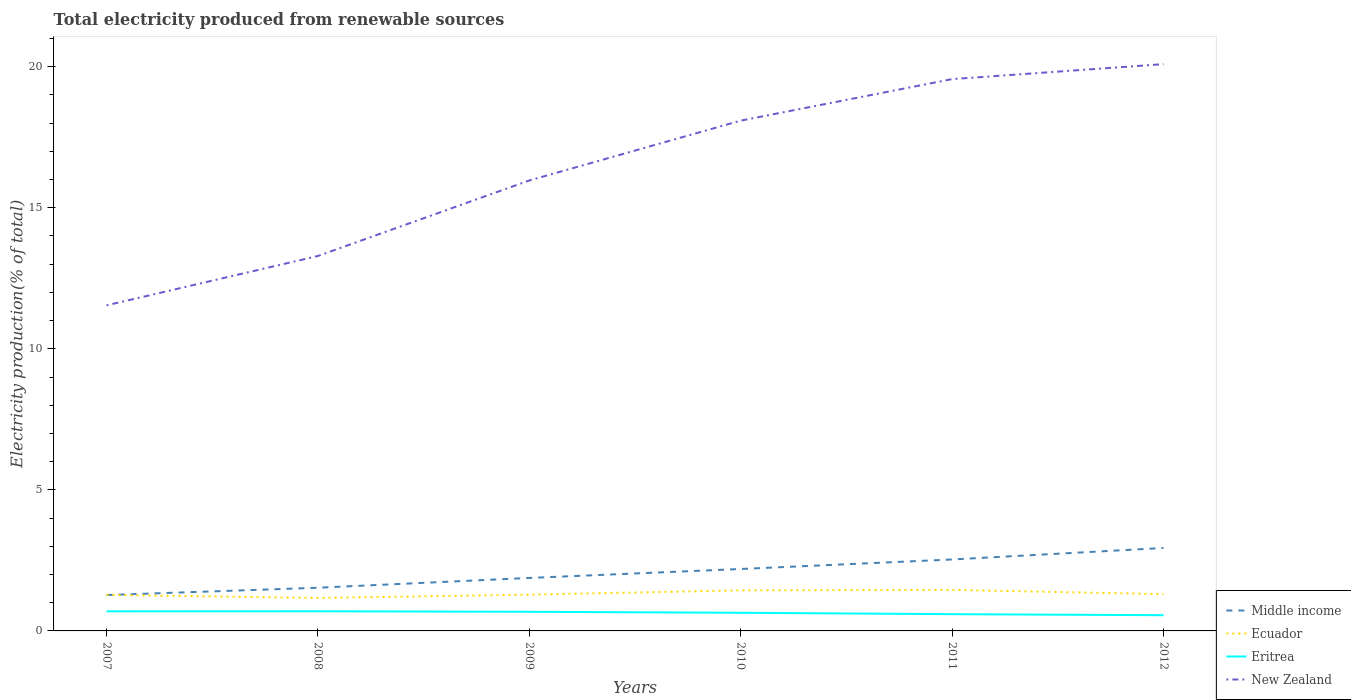Does the line corresponding to New Zealand intersect with the line corresponding to Eritrea?
Your answer should be compact. No. Is the number of lines equal to the number of legend labels?
Give a very brief answer. Yes. Across all years, what is the maximum total electricity produced in New Zealand?
Provide a succinct answer. 11.54. In which year was the total electricity produced in Middle income maximum?
Your answer should be compact. 2007. What is the total total electricity produced in Middle income in the graph?
Ensure brevity in your answer.  -0.26. What is the difference between the highest and the second highest total electricity produced in Ecuador?
Offer a very short reply. 0.29. Is the total electricity produced in New Zealand strictly greater than the total electricity produced in Eritrea over the years?
Offer a very short reply. No. How many years are there in the graph?
Your answer should be compact. 6. Are the values on the major ticks of Y-axis written in scientific E-notation?
Offer a terse response. No. Does the graph contain grids?
Offer a terse response. No. Where does the legend appear in the graph?
Your answer should be very brief. Bottom right. How many legend labels are there?
Your answer should be compact. 4. What is the title of the graph?
Offer a very short reply. Total electricity produced from renewable sources. What is the Electricity production(% of total) in Middle income in 2007?
Make the answer very short. 1.27. What is the Electricity production(% of total) in Ecuador in 2007?
Ensure brevity in your answer.  1.28. What is the Electricity production(% of total) of Eritrea in 2007?
Your answer should be very brief. 0.69. What is the Electricity production(% of total) in New Zealand in 2007?
Make the answer very short. 11.54. What is the Electricity production(% of total) in Middle income in 2008?
Provide a short and direct response. 1.53. What is the Electricity production(% of total) in Ecuador in 2008?
Offer a very short reply. 1.17. What is the Electricity production(% of total) of Eritrea in 2008?
Keep it short and to the point. 0.7. What is the Electricity production(% of total) of New Zealand in 2008?
Provide a short and direct response. 13.29. What is the Electricity production(% of total) in Middle income in 2009?
Your answer should be compact. 1.88. What is the Electricity production(% of total) in Ecuador in 2009?
Make the answer very short. 1.29. What is the Electricity production(% of total) in Eritrea in 2009?
Make the answer very short. 0.68. What is the Electricity production(% of total) of New Zealand in 2009?
Give a very brief answer. 15.97. What is the Electricity production(% of total) in Middle income in 2010?
Your answer should be compact. 2.2. What is the Electricity production(% of total) in Ecuador in 2010?
Offer a terse response. 1.44. What is the Electricity production(% of total) of Eritrea in 2010?
Provide a short and direct response. 0.64. What is the Electricity production(% of total) in New Zealand in 2010?
Give a very brief answer. 18.09. What is the Electricity production(% of total) in Middle income in 2011?
Your response must be concise. 2.53. What is the Electricity production(% of total) of Ecuador in 2011?
Provide a short and direct response. 1.45. What is the Electricity production(% of total) in Eritrea in 2011?
Your answer should be compact. 0.59. What is the Electricity production(% of total) in New Zealand in 2011?
Ensure brevity in your answer.  19.56. What is the Electricity production(% of total) in Middle income in 2012?
Keep it short and to the point. 2.94. What is the Electricity production(% of total) in Ecuador in 2012?
Provide a short and direct response. 1.3. What is the Electricity production(% of total) of Eritrea in 2012?
Offer a terse response. 0.56. What is the Electricity production(% of total) of New Zealand in 2012?
Ensure brevity in your answer.  20.09. Across all years, what is the maximum Electricity production(% of total) in Middle income?
Keep it short and to the point. 2.94. Across all years, what is the maximum Electricity production(% of total) of Ecuador?
Ensure brevity in your answer.  1.45. Across all years, what is the maximum Electricity production(% of total) in Eritrea?
Offer a very short reply. 0.7. Across all years, what is the maximum Electricity production(% of total) in New Zealand?
Offer a terse response. 20.09. Across all years, what is the minimum Electricity production(% of total) in Middle income?
Offer a terse response. 1.27. Across all years, what is the minimum Electricity production(% of total) of Ecuador?
Offer a terse response. 1.17. Across all years, what is the minimum Electricity production(% of total) of Eritrea?
Keep it short and to the point. 0.56. Across all years, what is the minimum Electricity production(% of total) in New Zealand?
Your answer should be very brief. 11.54. What is the total Electricity production(% of total) in Middle income in the graph?
Provide a succinct answer. 12.35. What is the total Electricity production(% of total) in Ecuador in the graph?
Give a very brief answer. 7.93. What is the total Electricity production(% of total) of Eritrea in the graph?
Your response must be concise. 3.86. What is the total Electricity production(% of total) of New Zealand in the graph?
Provide a short and direct response. 98.53. What is the difference between the Electricity production(% of total) in Middle income in 2007 and that in 2008?
Your response must be concise. -0.26. What is the difference between the Electricity production(% of total) in Ecuador in 2007 and that in 2008?
Make the answer very short. 0.11. What is the difference between the Electricity production(% of total) in Eritrea in 2007 and that in 2008?
Provide a short and direct response. -0. What is the difference between the Electricity production(% of total) of New Zealand in 2007 and that in 2008?
Ensure brevity in your answer.  -1.75. What is the difference between the Electricity production(% of total) in Middle income in 2007 and that in 2009?
Offer a terse response. -0.61. What is the difference between the Electricity production(% of total) of Ecuador in 2007 and that in 2009?
Your response must be concise. -0.01. What is the difference between the Electricity production(% of total) in Eritrea in 2007 and that in 2009?
Offer a very short reply. 0.02. What is the difference between the Electricity production(% of total) of New Zealand in 2007 and that in 2009?
Your answer should be compact. -4.43. What is the difference between the Electricity production(% of total) of Middle income in 2007 and that in 2010?
Give a very brief answer. -0.92. What is the difference between the Electricity production(% of total) in Ecuador in 2007 and that in 2010?
Your answer should be compact. -0.16. What is the difference between the Electricity production(% of total) in Eritrea in 2007 and that in 2010?
Provide a succinct answer. 0.05. What is the difference between the Electricity production(% of total) in New Zealand in 2007 and that in 2010?
Provide a short and direct response. -6.55. What is the difference between the Electricity production(% of total) of Middle income in 2007 and that in 2011?
Your answer should be compact. -1.26. What is the difference between the Electricity production(% of total) of Ecuador in 2007 and that in 2011?
Give a very brief answer. -0.18. What is the difference between the Electricity production(% of total) of Eritrea in 2007 and that in 2011?
Your response must be concise. 0.1. What is the difference between the Electricity production(% of total) in New Zealand in 2007 and that in 2011?
Make the answer very short. -8.02. What is the difference between the Electricity production(% of total) of Middle income in 2007 and that in 2012?
Make the answer very short. -1.67. What is the difference between the Electricity production(% of total) in Ecuador in 2007 and that in 2012?
Offer a very short reply. -0.03. What is the difference between the Electricity production(% of total) of Eritrea in 2007 and that in 2012?
Make the answer very short. 0.14. What is the difference between the Electricity production(% of total) of New Zealand in 2007 and that in 2012?
Ensure brevity in your answer.  -8.55. What is the difference between the Electricity production(% of total) in Middle income in 2008 and that in 2009?
Provide a short and direct response. -0.35. What is the difference between the Electricity production(% of total) of Ecuador in 2008 and that in 2009?
Offer a terse response. -0.12. What is the difference between the Electricity production(% of total) of Eritrea in 2008 and that in 2009?
Offer a terse response. 0.02. What is the difference between the Electricity production(% of total) in New Zealand in 2008 and that in 2009?
Give a very brief answer. -2.68. What is the difference between the Electricity production(% of total) in Middle income in 2008 and that in 2010?
Give a very brief answer. -0.66. What is the difference between the Electricity production(% of total) of Ecuador in 2008 and that in 2010?
Give a very brief answer. -0.27. What is the difference between the Electricity production(% of total) of Eritrea in 2008 and that in 2010?
Provide a short and direct response. 0.05. What is the difference between the Electricity production(% of total) of New Zealand in 2008 and that in 2010?
Provide a succinct answer. -4.8. What is the difference between the Electricity production(% of total) in Middle income in 2008 and that in 2011?
Provide a short and direct response. -1. What is the difference between the Electricity production(% of total) in Ecuador in 2008 and that in 2011?
Your answer should be compact. -0.29. What is the difference between the Electricity production(% of total) of Eritrea in 2008 and that in 2011?
Keep it short and to the point. 0.1. What is the difference between the Electricity production(% of total) in New Zealand in 2008 and that in 2011?
Your answer should be very brief. -6.27. What is the difference between the Electricity production(% of total) of Middle income in 2008 and that in 2012?
Your response must be concise. -1.41. What is the difference between the Electricity production(% of total) of Ecuador in 2008 and that in 2012?
Your response must be concise. -0.14. What is the difference between the Electricity production(% of total) in Eritrea in 2008 and that in 2012?
Ensure brevity in your answer.  0.14. What is the difference between the Electricity production(% of total) in New Zealand in 2008 and that in 2012?
Your answer should be very brief. -6.8. What is the difference between the Electricity production(% of total) of Middle income in 2009 and that in 2010?
Offer a terse response. -0.32. What is the difference between the Electricity production(% of total) of Ecuador in 2009 and that in 2010?
Offer a very short reply. -0.15. What is the difference between the Electricity production(% of total) of Eritrea in 2009 and that in 2010?
Offer a very short reply. 0.03. What is the difference between the Electricity production(% of total) of New Zealand in 2009 and that in 2010?
Give a very brief answer. -2.12. What is the difference between the Electricity production(% of total) of Middle income in 2009 and that in 2011?
Your answer should be very brief. -0.65. What is the difference between the Electricity production(% of total) in Ecuador in 2009 and that in 2011?
Offer a very short reply. -0.17. What is the difference between the Electricity production(% of total) in Eritrea in 2009 and that in 2011?
Your answer should be compact. 0.08. What is the difference between the Electricity production(% of total) of New Zealand in 2009 and that in 2011?
Keep it short and to the point. -3.59. What is the difference between the Electricity production(% of total) in Middle income in 2009 and that in 2012?
Offer a terse response. -1.06. What is the difference between the Electricity production(% of total) of Ecuador in 2009 and that in 2012?
Offer a terse response. -0.02. What is the difference between the Electricity production(% of total) of Eritrea in 2009 and that in 2012?
Make the answer very short. 0.12. What is the difference between the Electricity production(% of total) of New Zealand in 2009 and that in 2012?
Make the answer very short. -4.12. What is the difference between the Electricity production(% of total) in Middle income in 2010 and that in 2011?
Your answer should be compact. -0.34. What is the difference between the Electricity production(% of total) in Ecuador in 2010 and that in 2011?
Keep it short and to the point. -0.02. What is the difference between the Electricity production(% of total) of Eritrea in 2010 and that in 2011?
Ensure brevity in your answer.  0.05. What is the difference between the Electricity production(% of total) in New Zealand in 2010 and that in 2011?
Keep it short and to the point. -1.47. What is the difference between the Electricity production(% of total) of Middle income in 2010 and that in 2012?
Your response must be concise. -0.74. What is the difference between the Electricity production(% of total) of Ecuador in 2010 and that in 2012?
Give a very brief answer. 0.13. What is the difference between the Electricity production(% of total) in Eritrea in 2010 and that in 2012?
Make the answer very short. 0.09. What is the difference between the Electricity production(% of total) of New Zealand in 2010 and that in 2012?
Your answer should be compact. -2. What is the difference between the Electricity production(% of total) of Middle income in 2011 and that in 2012?
Offer a very short reply. -0.41. What is the difference between the Electricity production(% of total) in Ecuador in 2011 and that in 2012?
Give a very brief answer. 0.15. What is the difference between the Electricity production(% of total) in Eritrea in 2011 and that in 2012?
Offer a terse response. 0.04. What is the difference between the Electricity production(% of total) of New Zealand in 2011 and that in 2012?
Keep it short and to the point. -0.53. What is the difference between the Electricity production(% of total) in Middle income in 2007 and the Electricity production(% of total) in Ecuador in 2008?
Your response must be concise. 0.1. What is the difference between the Electricity production(% of total) of Middle income in 2007 and the Electricity production(% of total) of Eritrea in 2008?
Provide a short and direct response. 0.57. What is the difference between the Electricity production(% of total) of Middle income in 2007 and the Electricity production(% of total) of New Zealand in 2008?
Your answer should be very brief. -12.02. What is the difference between the Electricity production(% of total) of Ecuador in 2007 and the Electricity production(% of total) of Eritrea in 2008?
Give a very brief answer. 0.58. What is the difference between the Electricity production(% of total) of Ecuador in 2007 and the Electricity production(% of total) of New Zealand in 2008?
Offer a very short reply. -12.01. What is the difference between the Electricity production(% of total) in Eritrea in 2007 and the Electricity production(% of total) in New Zealand in 2008?
Make the answer very short. -12.6. What is the difference between the Electricity production(% of total) in Middle income in 2007 and the Electricity production(% of total) in Ecuador in 2009?
Ensure brevity in your answer.  -0.01. What is the difference between the Electricity production(% of total) in Middle income in 2007 and the Electricity production(% of total) in Eritrea in 2009?
Provide a succinct answer. 0.59. What is the difference between the Electricity production(% of total) of Middle income in 2007 and the Electricity production(% of total) of New Zealand in 2009?
Offer a terse response. -14.7. What is the difference between the Electricity production(% of total) in Ecuador in 2007 and the Electricity production(% of total) in Eritrea in 2009?
Offer a terse response. 0.6. What is the difference between the Electricity production(% of total) in Ecuador in 2007 and the Electricity production(% of total) in New Zealand in 2009?
Keep it short and to the point. -14.69. What is the difference between the Electricity production(% of total) in Eritrea in 2007 and the Electricity production(% of total) in New Zealand in 2009?
Your answer should be very brief. -15.27. What is the difference between the Electricity production(% of total) of Middle income in 2007 and the Electricity production(% of total) of Ecuador in 2010?
Offer a very short reply. -0.17. What is the difference between the Electricity production(% of total) in Middle income in 2007 and the Electricity production(% of total) in Eritrea in 2010?
Offer a terse response. 0.63. What is the difference between the Electricity production(% of total) of Middle income in 2007 and the Electricity production(% of total) of New Zealand in 2010?
Ensure brevity in your answer.  -16.82. What is the difference between the Electricity production(% of total) of Ecuador in 2007 and the Electricity production(% of total) of Eritrea in 2010?
Your answer should be compact. 0.63. What is the difference between the Electricity production(% of total) in Ecuador in 2007 and the Electricity production(% of total) in New Zealand in 2010?
Provide a succinct answer. -16.81. What is the difference between the Electricity production(% of total) in Eritrea in 2007 and the Electricity production(% of total) in New Zealand in 2010?
Ensure brevity in your answer.  -17.39. What is the difference between the Electricity production(% of total) of Middle income in 2007 and the Electricity production(% of total) of Ecuador in 2011?
Offer a very short reply. -0.18. What is the difference between the Electricity production(% of total) in Middle income in 2007 and the Electricity production(% of total) in Eritrea in 2011?
Your response must be concise. 0.68. What is the difference between the Electricity production(% of total) in Middle income in 2007 and the Electricity production(% of total) in New Zealand in 2011?
Offer a terse response. -18.29. What is the difference between the Electricity production(% of total) of Ecuador in 2007 and the Electricity production(% of total) of Eritrea in 2011?
Provide a succinct answer. 0.68. What is the difference between the Electricity production(% of total) in Ecuador in 2007 and the Electricity production(% of total) in New Zealand in 2011?
Your answer should be very brief. -18.28. What is the difference between the Electricity production(% of total) in Eritrea in 2007 and the Electricity production(% of total) in New Zealand in 2011?
Offer a terse response. -18.86. What is the difference between the Electricity production(% of total) in Middle income in 2007 and the Electricity production(% of total) in Ecuador in 2012?
Make the answer very short. -0.03. What is the difference between the Electricity production(% of total) of Middle income in 2007 and the Electricity production(% of total) of Eritrea in 2012?
Give a very brief answer. 0.71. What is the difference between the Electricity production(% of total) of Middle income in 2007 and the Electricity production(% of total) of New Zealand in 2012?
Keep it short and to the point. -18.82. What is the difference between the Electricity production(% of total) in Ecuador in 2007 and the Electricity production(% of total) in Eritrea in 2012?
Your response must be concise. 0.72. What is the difference between the Electricity production(% of total) in Ecuador in 2007 and the Electricity production(% of total) in New Zealand in 2012?
Your answer should be very brief. -18.81. What is the difference between the Electricity production(% of total) of Eritrea in 2007 and the Electricity production(% of total) of New Zealand in 2012?
Provide a short and direct response. -19.4. What is the difference between the Electricity production(% of total) of Middle income in 2008 and the Electricity production(% of total) of Ecuador in 2009?
Give a very brief answer. 0.25. What is the difference between the Electricity production(% of total) of Middle income in 2008 and the Electricity production(% of total) of Eritrea in 2009?
Ensure brevity in your answer.  0.85. What is the difference between the Electricity production(% of total) in Middle income in 2008 and the Electricity production(% of total) in New Zealand in 2009?
Your response must be concise. -14.44. What is the difference between the Electricity production(% of total) in Ecuador in 2008 and the Electricity production(% of total) in Eritrea in 2009?
Offer a terse response. 0.49. What is the difference between the Electricity production(% of total) of Ecuador in 2008 and the Electricity production(% of total) of New Zealand in 2009?
Offer a very short reply. -14.8. What is the difference between the Electricity production(% of total) in Eritrea in 2008 and the Electricity production(% of total) in New Zealand in 2009?
Provide a short and direct response. -15.27. What is the difference between the Electricity production(% of total) of Middle income in 2008 and the Electricity production(% of total) of Ecuador in 2010?
Your answer should be compact. 0.09. What is the difference between the Electricity production(% of total) in Middle income in 2008 and the Electricity production(% of total) in Eritrea in 2010?
Provide a succinct answer. 0.89. What is the difference between the Electricity production(% of total) in Middle income in 2008 and the Electricity production(% of total) in New Zealand in 2010?
Your response must be concise. -16.56. What is the difference between the Electricity production(% of total) in Ecuador in 2008 and the Electricity production(% of total) in Eritrea in 2010?
Keep it short and to the point. 0.53. What is the difference between the Electricity production(% of total) in Ecuador in 2008 and the Electricity production(% of total) in New Zealand in 2010?
Your answer should be very brief. -16.92. What is the difference between the Electricity production(% of total) in Eritrea in 2008 and the Electricity production(% of total) in New Zealand in 2010?
Provide a succinct answer. -17.39. What is the difference between the Electricity production(% of total) of Middle income in 2008 and the Electricity production(% of total) of Ecuador in 2011?
Provide a short and direct response. 0.08. What is the difference between the Electricity production(% of total) in Middle income in 2008 and the Electricity production(% of total) in Eritrea in 2011?
Provide a succinct answer. 0.94. What is the difference between the Electricity production(% of total) of Middle income in 2008 and the Electricity production(% of total) of New Zealand in 2011?
Make the answer very short. -18.03. What is the difference between the Electricity production(% of total) in Ecuador in 2008 and the Electricity production(% of total) in Eritrea in 2011?
Your answer should be compact. 0.58. What is the difference between the Electricity production(% of total) of Ecuador in 2008 and the Electricity production(% of total) of New Zealand in 2011?
Ensure brevity in your answer.  -18.39. What is the difference between the Electricity production(% of total) of Eritrea in 2008 and the Electricity production(% of total) of New Zealand in 2011?
Provide a succinct answer. -18.86. What is the difference between the Electricity production(% of total) of Middle income in 2008 and the Electricity production(% of total) of Ecuador in 2012?
Offer a very short reply. 0.23. What is the difference between the Electricity production(% of total) of Middle income in 2008 and the Electricity production(% of total) of Eritrea in 2012?
Your response must be concise. 0.97. What is the difference between the Electricity production(% of total) of Middle income in 2008 and the Electricity production(% of total) of New Zealand in 2012?
Your response must be concise. -18.56. What is the difference between the Electricity production(% of total) in Ecuador in 2008 and the Electricity production(% of total) in Eritrea in 2012?
Offer a terse response. 0.61. What is the difference between the Electricity production(% of total) of Ecuador in 2008 and the Electricity production(% of total) of New Zealand in 2012?
Make the answer very short. -18.92. What is the difference between the Electricity production(% of total) in Eritrea in 2008 and the Electricity production(% of total) in New Zealand in 2012?
Offer a very short reply. -19.39. What is the difference between the Electricity production(% of total) in Middle income in 2009 and the Electricity production(% of total) in Ecuador in 2010?
Keep it short and to the point. 0.44. What is the difference between the Electricity production(% of total) in Middle income in 2009 and the Electricity production(% of total) in Eritrea in 2010?
Your answer should be very brief. 1.23. What is the difference between the Electricity production(% of total) in Middle income in 2009 and the Electricity production(% of total) in New Zealand in 2010?
Offer a very short reply. -16.21. What is the difference between the Electricity production(% of total) of Ecuador in 2009 and the Electricity production(% of total) of Eritrea in 2010?
Your answer should be very brief. 0.64. What is the difference between the Electricity production(% of total) of Ecuador in 2009 and the Electricity production(% of total) of New Zealand in 2010?
Your answer should be very brief. -16.8. What is the difference between the Electricity production(% of total) of Eritrea in 2009 and the Electricity production(% of total) of New Zealand in 2010?
Keep it short and to the point. -17.41. What is the difference between the Electricity production(% of total) of Middle income in 2009 and the Electricity production(% of total) of Ecuador in 2011?
Provide a succinct answer. 0.42. What is the difference between the Electricity production(% of total) of Middle income in 2009 and the Electricity production(% of total) of Eritrea in 2011?
Your response must be concise. 1.28. What is the difference between the Electricity production(% of total) in Middle income in 2009 and the Electricity production(% of total) in New Zealand in 2011?
Provide a succinct answer. -17.68. What is the difference between the Electricity production(% of total) of Ecuador in 2009 and the Electricity production(% of total) of Eritrea in 2011?
Offer a very short reply. 0.69. What is the difference between the Electricity production(% of total) in Ecuador in 2009 and the Electricity production(% of total) in New Zealand in 2011?
Keep it short and to the point. -18.27. What is the difference between the Electricity production(% of total) in Eritrea in 2009 and the Electricity production(% of total) in New Zealand in 2011?
Give a very brief answer. -18.88. What is the difference between the Electricity production(% of total) of Middle income in 2009 and the Electricity production(% of total) of Ecuador in 2012?
Provide a short and direct response. 0.57. What is the difference between the Electricity production(% of total) of Middle income in 2009 and the Electricity production(% of total) of Eritrea in 2012?
Provide a short and direct response. 1.32. What is the difference between the Electricity production(% of total) in Middle income in 2009 and the Electricity production(% of total) in New Zealand in 2012?
Your answer should be compact. -18.21. What is the difference between the Electricity production(% of total) in Ecuador in 2009 and the Electricity production(% of total) in Eritrea in 2012?
Give a very brief answer. 0.73. What is the difference between the Electricity production(% of total) in Ecuador in 2009 and the Electricity production(% of total) in New Zealand in 2012?
Keep it short and to the point. -18.8. What is the difference between the Electricity production(% of total) in Eritrea in 2009 and the Electricity production(% of total) in New Zealand in 2012?
Keep it short and to the point. -19.41. What is the difference between the Electricity production(% of total) of Middle income in 2010 and the Electricity production(% of total) of Ecuador in 2011?
Make the answer very short. 0.74. What is the difference between the Electricity production(% of total) in Middle income in 2010 and the Electricity production(% of total) in Eritrea in 2011?
Provide a short and direct response. 1.6. What is the difference between the Electricity production(% of total) in Middle income in 2010 and the Electricity production(% of total) in New Zealand in 2011?
Offer a very short reply. -17.36. What is the difference between the Electricity production(% of total) in Ecuador in 2010 and the Electricity production(% of total) in Eritrea in 2011?
Keep it short and to the point. 0.84. What is the difference between the Electricity production(% of total) in Ecuador in 2010 and the Electricity production(% of total) in New Zealand in 2011?
Offer a terse response. -18.12. What is the difference between the Electricity production(% of total) in Eritrea in 2010 and the Electricity production(% of total) in New Zealand in 2011?
Your answer should be compact. -18.92. What is the difference between the Electricity production(% of total) in Middle income in 2010 and the Electricity production(% of total) in Ecuador in 2012?
Your answer should be very brief. 0.89. What is the difference between the Electricity production(% of total) of Middle income in 2010 and the Electricity production(% of total) of Eritrea in 2012?
Your answer should be compact. 1.64. What is the difference between the Electricity production(% of total) in Middle income in 2010 and the Electricity production(% of total) in New Zealand in 2012?
Provide a succinct answer. -17.89. What is the difference between the Electricity production(% of total) in Ecuador in 2010 and the Electricity production(% of total) in Eritrea in 2012?
Provide a succinct answer. 0.88. What is the difference between the Electricity production(% of total) of Ecuador in 2010 and the Electricity production(% of total) of New Zealand in 2012?
Provide a short and direct response. -18.65. What is the difference between the Electricity production(% of total) in Eritrea in 2010 and the Electricity production(% of total) in New Zealand in 2012?
Ensure brevity in your answer.  -19.45. What is the difference between the Electricity production(% of total) of Middle income in 2011 and the Electricity production(% of total) of Ecuador in 2012?
Make the answer very short. 1.23. What is the difference between the Electricity production(% of total) in Middle income in 2011 and the Electricity production(% of total) in Eritrea in 2012?
Your response must be concise. 1.98. What is the difference between the Electricity production(% of total) in Middle income in 2011 and the Electricity production(% of total) in New Zealand in 2012?
Keep it short and to the point. -17.56. What is the difference between the Electricity production(% of total) in Ecuador in 2011 and the Electricity production(% of total) in Eritrea in 2012?
Your answer should be compact. 0.9. What is the difference between the Electricity production(% of total) of Ecuador in 2011 and the Electricity production(% of total) of New Zealand in 2012?
Give a very brief answer. -18.64. What is the difference between the Electricity production(% of total) in Eritrea in 2011 and the Electricity production(% of total) in New Zealand in 2012?
Ensure brevity in your answer.  -19.5. What is the average Electricity production(% of total) in Middle income per year?
Provide a succinct answer. 2.06. What is the average Electricity production(% of total) of Ecuador per year?
Provide a succinct answer. 1.32. What is the average Electricity production(% of total) in Eritrea per year?
Ensure brevity in your answer.  0.64. What is the average Electricity production(% of total) in New Zealand per year?
Keep it short and to the point. 16.42. In the year 2007, what is the difference between the Electricity production(% of total) in Middle income and Electricity production(% of total) in Ecuador?
Offer a very short reply. -0.01. In the year 2007, what is the difference between the Electricity production(% of total) in Middle income and Electricity production(% of total) in Eritrea?
Your response must be concise. 0.58. In the year 2007, what is the difference between the Electricity production(% of total) in Middle income and Electricity production(% of total) in New Zealand?
Your response must be concise. -10.27. In the year 2007, what is the difference between the Electricity production(% of total) of Ecuador and Electricity production(% of total) of Eritrea?
Keep it short and to the point. 0.58. In the year 2007, what is the difference between the Electricity production(% of total) of Ecuador and Electricity production(% of total) of New Zealand?
Provide a short and direct response. -10.26. In the year 2007, what is the difference between the Electricity production(% of total) of Eritrea and Electricity production(% of total) of New Zealand?
Your answer should be compact. -10.85. In the year 2008, what is the difference between the Electricity production(% of total) in Middle income and Electricity production(% of total) in Ecuador?
Give a very brief answer. 0.36. In the year 2008, what is the difference between the Electricity production(% of total) of Middle income and Electricity production(% of total) of Eritrea?
Make the answer very short. 0.83. In the year 2008, what is the difference between the Electricity production(% of total) in Middle income and Electricity production(% of total) in New Zealand?
Ensure brevity in your answer.  -11.76. In the year 2008, what is the difference between the Electricity production(% of total) in Ecuador and Electricity production(% of total) in Eritrea?
Ensure brevity in your answer.  0.47. In the year 2008, what is the difference between the Electricity production(% of total) of Ecuador and Electricity production(% of total) of New Zealand?
Give a very brief answer. -12.12. In the year 2008, what is the difference between the Electricity production(% of total) of Eritrea and Electricity production(% of total) of New Zealand?
Your response must be concise. -12.59. In the year 2009, what is the difference between the Electricity production(% of total) of Middle income and Electricity production(% of total) of Ecuador?
Your response must be concise. 0.59. In the year 2009, what is the difference between the Electricity production(% of total) in Middle income and Electricity production(% of total) in Eritrea?
Ensure brevity in your answer.  1.2. In the year 2009, what is the difference between the Electricity production(% of total) in Middle income and Electricity production(% of total) in New Zealand?
Offer a very short reply. -14.09. In the year 2009, what is the difference between the Electricity production(% of total) of Ecuador and Electricity production(% of total) of Eritrea?
Your response must be concise. 0.61. In the year 2009, what is the difference between the Electricity production(% of total) in Ecuador and Electricity production(% of total) in New Zealand?
Offer a very short reply. -14.68. In the year 2009, what is the difference between the Electricity production(% of total) of Eritrea and Electricity production(% of total) of New Zealand?
Offer a very short reply. -15.29. In the year 2010, what is the difference between the Electricity production(% of total) in Middle income and Electricity production(% of total) in Ecuador?
Offer a terse response. 0.76. In the year 2010, what is the difference between the Electricity production(% of total) in Middle income and Electricity production(% of total) in Eritrea?
Make the answer very short. 1.55. In the year 2010, what is the difference between the Electricity production(% of total) in Middle income and Electricity production(% of total) in New Zealand?
Offer a terse response. -15.89. In the year 2010, what is the difference between the Electricity production(% of total) of Ecuador and Electricity production(% of total) of Eritrea?
Give a very brief answer. 0.79. In the year 2010, what is the difference between the Electricity production(% of total) in Ecuador and Electricity production(% of total) in New Zealand?
Provide a short and direct response. -16.65. In the year 2010, what is the difference between the Electricity production(% of total) in Eritrea and Electricity production(% of total) in New Zealand?
Make the answer very short. -17.44. In the year 2011, what is the difference between the Electricity production(% of total) of Middle income and Electricity production(% of total) of Ecuador?
Provide a succinct answer. 1.08. In the year 2011, what is the difference between the Electricity production(% of total) in Middle income and Electricity production(% of total) in Eritrea?
Your answer should be very brief. 1.94. In the year 2011, what is the difference between the Electricity production(% of total) in Middle income and Electricity production(% of total) in New Zealand?
Your answer should be compact. -17.03. In the year 2011, what is the difference between the Electricity production(% of total) of Ecuador and Electricity production(% of total) of Eritrea?
Provide a short and direct response. 0.86. In the year 2011, what is the difference between the Electricity production(% of total) in Ecuador and Electricity production(% of total) in New Zealand?
Your response must be concise. -18.11. In the year 2011, what is the difference between the Electricity production(% of total) of Eritrea and Electricity production(% of total) of New Zealand?
Your answer should be compact. -18.97. In the year 2012, what is the difference between the Electricity production(% of total) in Middle income and Electricity production(% of total) in Ecuador?
Ensure brevity in your answer.  1.64. In the year 2012, what is the difference between the Electricity production(% of total) of Middle income and Electricity production(% of total) of Eritrea?
Make the answer very short. 2.38. In the year 2012, what is the difference between the Electricity production(% of total) in Middle income and Electricity production(% of total) in New Zealand?
Keep it short and to the point. -17.15. In the year 2012, what is the difference between the Electricity production(% of total) of Ecuador and Electricity production(% of total) of Eritrea?
Keep it short and to the point. 0.75. In the year 2012, what is the difference between the Electricity production(% of total) of Ecuador and Electricity production(% of total) of New Zealand?
Keep it short and to the point. -18.79. In the year 2012, what is the difference between the Electricity production(% of total) of Eritrea and Electricity production(% of total) of New Zealand?
Provide a succinct answer. -19.53. What is the ratio of the Electricity production(% of total) of Middle income in 2007 to that in 2008?
Your answer should be compact. 0.83. What is the ratio of the Electricity production(% of total) in Ecuador in 2007 to that in 2008?
Offer a very short reply. 1.09. What is the ratio of the Electricity production(% of total) of Eritrea in 2007 to that in 2008?
Your answer should be very brief. 1. What is the ratio of the Electricity production(% of total) in New Zealand in 2007 to that in 2008?
Provide a succinct answer. 0.87. What is the ratio of the Electricity production(% of total) in Middle income in 2007 to that in 2009?
Provide a succinct answer. 0.68. What is the ratio of the Electricity production(% of total) in Eritrea in 2007 to that in 2009?
Offer a terse response. 1.02. What is the ratio of the Electricity production(% of total) in New Zealand in 2007 to that in 2009?
Offer a very short reply. 0.72. What is the ratio of the Electricity production(% of total) of Middle income in 2007 to that in 2010?
Provide a short and direct response. 0.58. What is the ratio of the Electricity production(% of total) in Ecuador in 2007 to that in 2010?
Provide a succinct answer. 0.89. What is the ratio of the Electricity production(% of total) in Eritrea in 2007 to that in 2010?
Provide a short and direct response. 1.08. What is the ratio of the Electricity production(% of total) in New Zealand in 2007 to that in 2010?
Ensure brevity in your answer.  0.64. What is the ratio of the Electricity production(% of total) in Middle income in 2007 to that in 2011?
Ensure brevity in your answer.  0.5. What is the ratio of the Electricity production(% of total) of Ecuador in 2007 to that in 2011?
Ensure brevity in your answer.  0.88. What is the ratio of the Electricity production(% of total) in Eritrea in 2007 to that in 2011?
Offer a terse response. 1.17. What is the ratio of the Electricity production(% of total) in New Zealand in 2007 to that in 2011?
Your answer should be compact. 0.59. What is the ratio of the Electricity production(% of total) in Middle income in 2007 to that in 2012?
Provide a succinct answer. 0.43. What is the ratio of the Electricity production(% of total) in Ecuador in 2007 to that in 2012?
Offer a very short reply. 0.98. What is the ratio of the Electricity production(% of total) in Eritrea in 2007 to that in 2012?
Ensure brevity in your answer.  1.25. What is the ratio of the Electricity production(% of total) of New Zealand in 2007 to that in 2012?
Keep it short and to the point. 0.57. What is the ratio of the Electricity production(% of total) in Middle income in 2008 to that in 2009?
Give a very brief answer. 0.82. What is the ratio of the Electricity production(% of total) in Ecuador in 2008 to that in 2009?
Your response must be concise. 0.91. What is the ratio of the Electricity production(% of total) of Eritrea in 2008 to that in 2009?
Offer a terse response. 1.03. What is the ratio of the Electricity production(% of total) in New Zealand in 2008 to that in 2009?
Provide a short and direct response. 0.83. What is the ratio of the Electricity production(% of total) in Middle income in 2008 to that in 2010?
Your answer should be compact. 0.7. What is the ratio of the Electricity production(% of total) in Ecuador in 2008 to that in 2010?
Keep it short and to the point. 0.81. What is the ratio of the Electricity production(% of total) in Eritrea in 2008 to that in 2010?
Offer a very short reply. 1.08. What is the ratio of the Electricity production(% of total) in New Zealand in 2008 to that in 2010?
Offer a terse response. 0.73. What is the ratio of the Electricity production(% of total) of Middle income in 2008 to that in 2011?
Offer a terse response. 0.6. What is the ratio of the Electricity production(% of total) of Ecuador in 2008 to that in 2011?
Your response must be concise. 0.8. What is the ratio of the Electricity production(% of total) in Eritrea in 2008 to that in 2011?
Keep it short and to the point. 1.17. What is the ratio of the Electricity production(% of total) in New Zealand in 2008 to that in 2011?
Offer a very short reply. 0.68. What is the ratio of the Electricity production(% of total) in Middle income in 2008 to that in 2012?
Give a very brief answer. 0.52. What is the ratio of the Electricity production(% of total) of Ecuador in 2008 to that in 2012?
Your response must be concise. 0.9. What is the ratio of the Electricity production(% of total) in Eritrea in 2008 to that in 2012?
Provide a succinct answer. 1.25. What is the ratio of the Electricity production(% of total) of New Zealand in 2008 to that in 2012?
Give a very brief answer. 0.66. What is the ratio of the Electricity production(% of total) of Middle income in 2009 to that in 2010?
Your answer should be compact. 0.86. What is the ratio of the Electricity production(% of total) of Ecuador in 2009 to that in 2010?
Make the answer very short. 0.89. What is the ratio of the Electricity production(% of total) of Eritrea in 2009 to that in 2010?
Give a very brief answer. 1.05. What is the ratio of the Electricity production(% of total) in New Zealand in 2009 to that in 2010?
Provide a succinct answer. 0.88. What is the ratio of the Electricity production(% of total) of Middle income in 2009 to that in 2011?
Keep it short and to the point. 0.74. What is the ratio of the Electricity production(% of total) in Ecuador in 2009 to that in 2011?
Make the answer very short. 0.88. What is the ratio of the Electricity production(% of total) in Eritrea in 2009 to that in 2011?
Keep it short and to the point. 1.14. What is the ratio of the Electricity production(% of total) of New Zealand in 2009 to that in 2011?
Provide a short and direct response. 0.82. What is the ratio of the Electricity production(% of total) of Middle income in 2009 to that in 2012?
Make the answer very short. 0.64. What is the ratio of the Electricity production(% of total) in Ecuador in 2009 to that in 2012?
Give a very brief answer. 0.99. What is the ratio of the Electricity production(% of total) in Eritrea in 2009 to that in 2012?
Offer a terse response. 1.22. What is the ratio of the Electricity production(% of total) of New Zealand in 2009 to that in 2012?
Provide a short and direct response. 0.79. What is the ratio of the Electricity production(% of total) in Middle income in 2010 to that in 2011?
Give a very brief answer. 0.87. What is the ratio of the Electricity production(% of total) in Ecuador in 2010 to that in 2011?
Your answer should be compact. 0.99. What is the ratio of the Electricity production(% of total) in Eritrea in 2010 to that in 2011?
Keep it short and to the point. 1.08. What is the ratio of the Electricity production(% of total) in New Zealand in 2010 to that in 2011?
Your answer should be compact. 0.92. What is the ratio of the Electricity production(% of total) of Middle income in 2010 to that in 2012?
Offer a terse response. 0.75. What is the ratio of the Electricity production(% of total) in Ecuador in 2010 to that in 2012?
Provide a succinct answer. 1.1. What is the ratio of the Electricity production(% of total) of Eritrea in 2010 to that in 2012?
Your response must be concise. 1.15. What is the ratio of the Electricity production(% of total) of New Zealand in 2010 to that in 2012?
Your answer should be very brief. 0.9. What is the ratio of the Electricity production(% of total) of Middle income in 2011 to that in 2012?
Provide a succinct answer. 0.86. What is the ratio of the Electricity production(% of total) of Ecuador in 2011 to that in 2012?
Keep it short and to the point. 1.11. What is the ratio of the Electricity production(% of total) in Eritrea in 2011 to that in 2012?
Ensure brevity in your answer.  1.07. What is the ratio of the Electricity production(% of total) in New Zealand in 2011 to that in 2012?
Provide a short and direct response. 0.97. What is the difference between the highest and the second highest Electricity production(% of total) in Middle income?
Provide a short and direct response. 0.41. What is the difference between the highest and the second highest Electricity production(% of total) of Ecuador?
Give a very brief answer. 0.02. What is the difference between the highest and the second highest Electricity production(% of total) of Eritrea?
Make the answer very short. 0. What is the difference between the highest and the second highest Electricity production(% of total) of New Zealand?
Offer a very short reply. 0.53. What is the difference between the highest and the lowest Electricity production(% of total) of Middle income?
Offer a terse response. 1.67. What is the difference between the highest and the lowest Electricity production(% of total) in Ecuador?
Make the answer very short. 0.29. What is the difference between the highest and the lowest Electricity production(% of total) in Eritrea?
Give a very brief answer. 0.14. What is the difference between the highest and the lowest Electricity production(% of total) of New Zealand?
Offer a terse response. 8.55. 